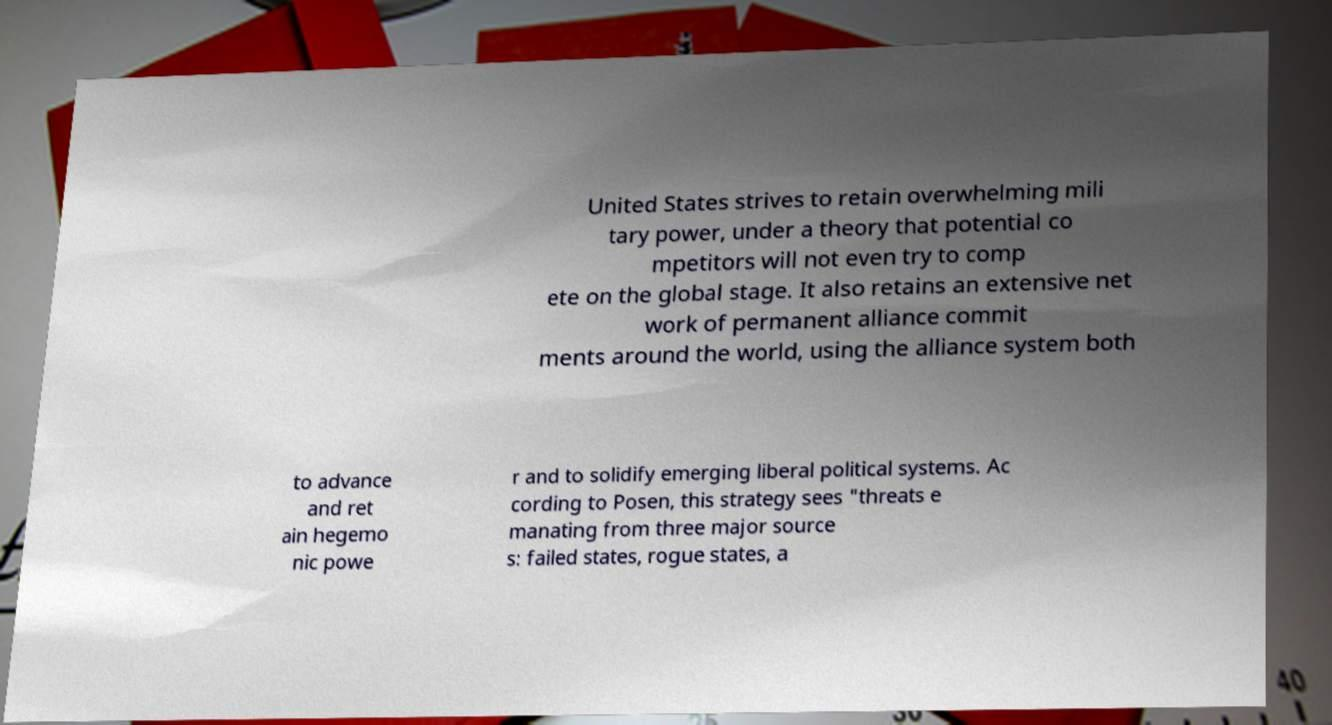Can you read and provide the text displayed in the image?This photo seems to have some interesting text. Can you extract and type it out for me? United States strives to retain overwhelming mili tary power, under a theory that potential co mpetitors will not even try to comp ete on the global stage. It also retains an extensive net work of permanent alliance commit ments around the world, using the alliance system both to advance and ret ain hegemo nic powe r and to solidify emerging liberal political systems. Ac cording to Posen, this strategy sees "threats e manating from three major source s: failed states, rogue states, a 